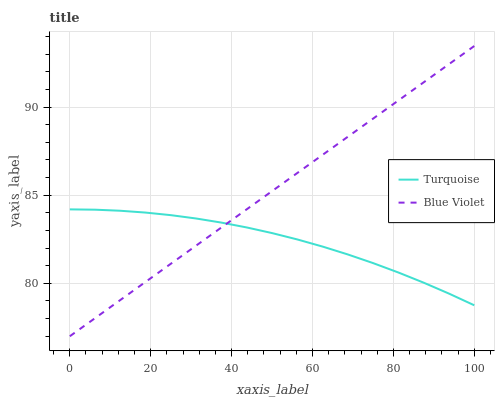Does Turquoise have the minimum area under the curve?
Answer yes or no. Yes. Does Blue Violet have the maximum area under the curve?
Answer yes or no. Yes. Does Blue Violet have the minimum area under the curve?
Answer yes or no. No. Is Blue Violet the smoothest?
Answer yes or no. Yes. Is Turquoise the roughest?
Answer yes or no. Yes. Is Blue Violet the roughest?
Answer yes or no. No. Does Blue Violet have the lowest value?
Answer yes or no. Yes. Does Blue Violet have the highest value?
Answer yes or no. Yes. Does Turquoise intersect Blue Violet?
Answer yes or no. Yes. Is Turquoise less than Blue Violet?
Answer yes or no. No. Is Turquoise greater than Blue Violet?
Answer yes or no. No. 